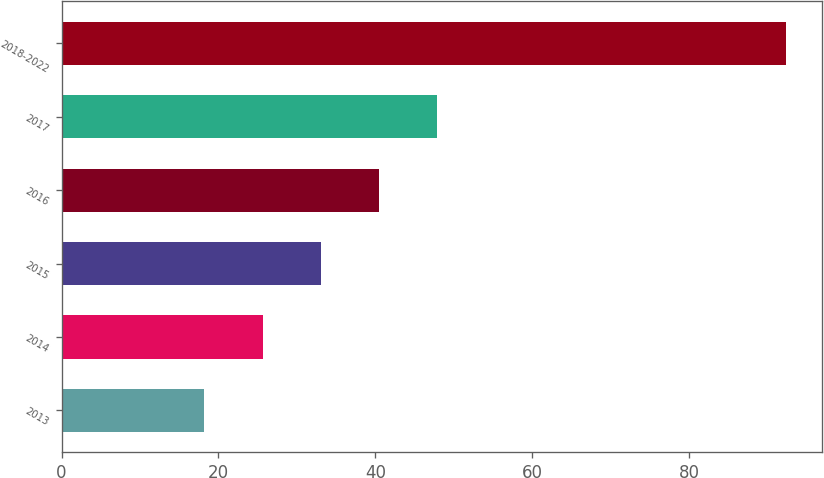<chart> <loc_0><loc_0><loc_500><loc_500><bar_chart><fcel>2013<fcel>2014<fcel>2015<fcel>2016<fcel>2017<fcel>2018-2022<nl><fcel>18.2<fcel>25.61<fcel>33.02<fcel>40.43<fcel>47.84<fcel>92.3<nl></chart> 